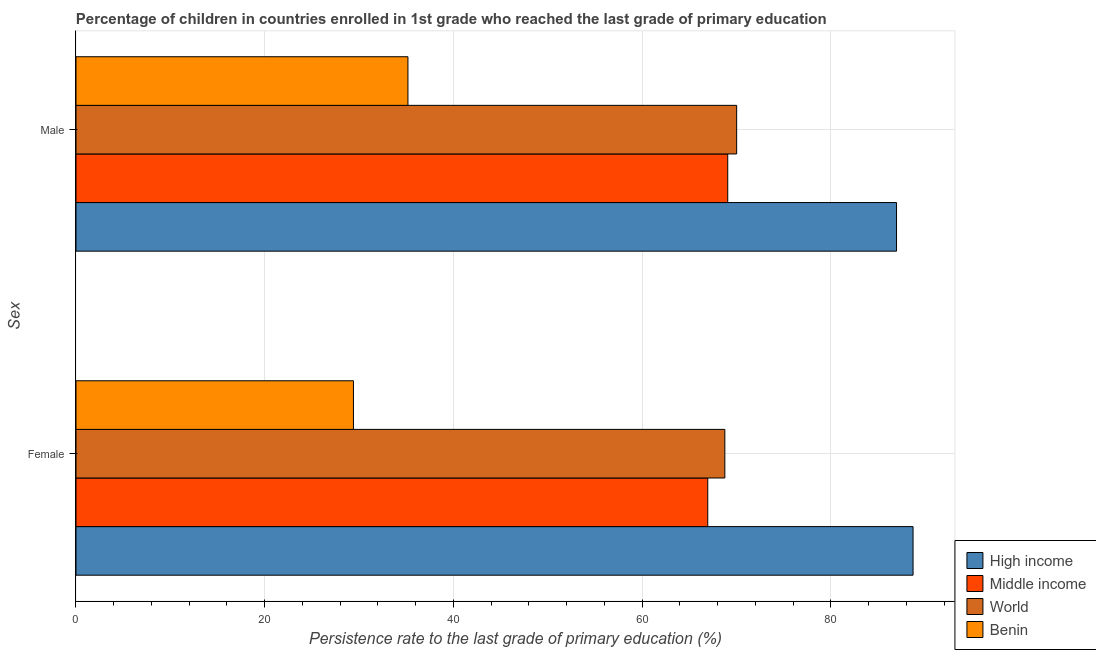How many different coloured bars are there?
Your response must be concise. 4. Are the number of bars per tick equal to the number of legend labels?
Provide a succinct answer. Yes. How many bars are there on the 1st tick from the top?
Provide a short and direct response. 4. What is the persistence rate of female students in Middle income?
Your answer should be compact. 66.95. Across all countries, what is the maximum persistence rate of female students?
Ensure brevity in your answer.  88.71. Across all countries, what is the minimum persistence rate of male students?
Keep it short and to the point. 35.18. In which country was the persistence rate of male students minimum?
Make the answer very short. Benin. What is the total persistence rate of female students in the graph?
Your response must be concise. 253.82. What is the difference between the persistence rate of female students in High income and that in Benin?
Offer a very short reply. 59.3. What is the difference between the persistence rate of female students in High income and the persistence rate of male students in Benin?
Give a very brief answer. 53.53. What is the average persistence rate of female students per country?
Your response must be concise. 63.45. What is the difference between the persistence rate of male students and persistence rate of female students in High income?
Your answer should be very brief. -1.75. What is the ratio of the persistence rate of male students in Middle income to that in Benin?
Ensure brevity in your answer.  1.96. In how many countries, is the persistence rate of male students greater than the average persistence rate of male students taken over all countries?
Provide a succinct answer. 3. How many countries are there in the graph?
Your response must be concise. 4. Are the values on the major ticks of X-axis written in scientific E-notation?
Provide a succinct answer. No. Does the graph contain any zero values?
Keep it short and to the point. No. How many legend labels are there?
Ensure brevity in your answer.  4. How are the legend labels stacked?
Give a very brief answer. Vertical. What is the title of the graph?
Keep it short and to the point. Percentage of children in countries enrolled in 1st grade who reached the last grade of primary education. Does "Estonia" appear as one of the legend labels in the graph?
Your answer should be compact. No. What is the label or title of the X-axis?
Give a very brief answer. Persistence rate to the last grade of primary education (%). What is the label or title of the Y-axis?
Your response must be concise. Sex. What is the Persistence rate to the last grade of primary education (%) of High income in Female?
Give a very brief answer. 88.71. What is the Persistence rate to the last grade of primary education (%) of Middle income in Female?
Offer a terse response. 66.95. What is the Persistence rate to the last grade of primary education (%) of World in Female?
Provide a short and direct response. 68.76. What is the Persistence rate to the last grade of primary education (%) of Benin in Female?
Your response must be concise. 29.4. What is the Persistence rate to the last grade of primary education (%) of High income in Male?
Make the answer very short. 86.95. What is the Persistence rate to the last grade of primary education (%) in Middle income in Male?
Your response must be concise. 69.07. What is the Persistence rate to the last grade of primary education (%) in World in Male?
Make the answer very short. 70.01. What is the Persistence rate to the last grade of primary education (%) in Benin in Male?
Your answer should be very brief. 35.18. Across all Sex, what is the maximum Persistence rate to the last grade of primary education (%) of High income?
Ensure brevity in your answer.  88.71. Across all Sex, what is the maximum Persistence rate to the last grade of primary education (%) of Middle income?
Your answer should be very brief. 69.07. Across all Sex, what is the maximum Persistence rate to the last grade of primary education (%) of World?
Offer a very short reply. 70.01. Across all Sex, what is the maximum Persistence rate to the last grade of primary education (%) in Benin?
Keep it short and to the point. 35.18. Across all Sex, what is the minimum Persistence rate to the last grade of primary education (%) of High income?
Keep it short and to the point. 86.95. Across all Sex, what is the minimum Persistence rate to the last grade of primary education (%) of Middle income?
Offer a very short reply. 66.95. Across all Sex, what is the minimum Persistence rate to the last grade of primary education (%) of World?
Your answer should be compact. 68.76. Across all Sex, what is the minimum Persistence rate to the last grade of primary education (%) of Benin?
Ensure brevity in your answer.  29.4. What is the total Persistence rate to the last grade of primary education (%) in High income in the graph?
Make the answer very short. 175.66. What is the total Persistence rate to the last grade of primary education (%) of Middle income in the graph?
Ensure brevity in your answer.  136.02. What is the total Persistence rate to the last grade of primary education (%) of World in the graph?
Make the answer very short. 138.77. What is the total Persistence rate to the last grade of primary education (%) of Benin in the graph?
Offer a very short reply. 64.58. What is the difference between the Persistence rate to the last grade of primary education (%) of High income in Female and that in Male?
Your answer should be very brief. 1.75. What is the difference between the Persistence rate to the last grade of primary education (%) of Middle income in Female and that in Male?
Give a very brief answer. -2.12. What is the difference between the Persistence rate to the last grade of primary education (%) of World in Female and that in Male?
Offer a very short reply. -1.25. What is the difference between the Persistence rate to the last grade of primary education (%) in Benin in Female and that in Male?
Provide a short and direct response. -5.77. What is the difference between the Persistence rate to the last grade of primary education (%) of High income in Female and the Persistence rate to the last grade of primary education (%) of Middle income in Male?
Keep it short and to the point. 19.64. What is the difference between the Persistence rate to the last grade of primary education (%) in High income in Female and the Persistence rate to the last grade of primary education (%) in World in Male?
Provide a short and direct response. 18.69. What is the difference between the Persistence rate to the last grade of primary education (%) of High income in Female and the Persistence rate to the last grade of primary education (%) of Benin in Male?
Your response must be concise. 53.53. What is the difference between the Persistence rate to the last grade of primary education (%) in Middle income in Female and the Persistence rate to the last grade of primary education (%) in World in Male?
Make the answer very short. -3.06. What is the difference between the Persistence rate to the last grade of primary education (%) of Middle income in Female and the Persistence rate to the last grade of primary education (%) of Benin in Male?
Give a very brief answer. 31.77. What is the difference between the Persistence rate to the last grade of primary education (%) of World in Female and the Persistence rate to the last grade of primary education (%) of Benin in Male?
Provide a succinct answer. 33.58. What is the average Persistence rate to the last grade of primary education (%) of High income per Sex?
Give a very brief answer. 87.83. What is the average Persistence rate to the last grade of primary education (%) in Middle income per Sex?
Make the answer very short. 68.01. What is the average Persistence rate to the last grade of primary education (%) in World per Sex?
Your answer should be compact. 69.39. What is the average Persistence rate to the last grade of primary education (%) in Benin per Sex?
Give a very brief answer. 32.29. What is the difference between the Persistence rate to the last grade of primary education (%) of High income and Persistence rate to the last grade of primary education (%) of Middle income in Female?
Offer a very short reply. 21.76. What is the difference between the Persistence rate to the last grade of primary education (%) in High income and Persistence rate to the last grade of primary education (%) in World in Female?
Make the answer very short. 19.95. What is the difference between the Persistence rate to the last grade of primary education (%) of High income and Persistence rate to the last grade of primary education (%) of Benin in Female?
Provide a short and direct response. 59.3. What is the difference between the Persistence rate to the last grade of primary education (%) of Middle income and Persistence rate to the last grade of primary education (%) of World in Female?
Make the answer very short. -1.81. What is the difference between the Persistence rate to the last grade of primary education (%) of Middle income and Persistence rate to the last grade of primary education (%) of Benin in Female?
Ensure brevity in your answer.  37.55. What is the difference between the Persistence rate to the last grade of primary education (%) of World and Persistence rate to the last grade of primary education (%) of Benin in Female?
Make the answer very short. 39.36. What is the difference between the Persistence rate to the last grade of primary education (%) in High income and Persistence rate to the last grade of primary education (%) in Middle income in Male?
Give a very brief answer. 17.89. What is the difference between the Persistence rate to the last grade of primary education (%) in High income and Persistence rate to the last grade of primary education (%) in World in Male?
Your answer should be very brief. 16.94. What is the difference between the Persistence rate to the last grade of primary education (%) of High income and Persistence rate to the last grade of primary education (%) of Benin in Male?
Keep it short and to the point. 51.78. What is the difference between the Persistence rate to the last grade of primary education (%) of Middle income and Persistence rate to the last grade of primary education (%) of World in Male?
Offer a very short reply. -0.94. What is the difference between the Persistence rate to the last grade of primary education (%) in Middle income and Persistence rate to the last grade of primary education (%) in Benin in Male?
Provide a short and direct response. 33.89. What is the difference between the Persistence rate to the last grade of primary education (%) of World and Persistence rate to the last grade of primary education (%) of Benin in Male?
Offer a terse response. 34.83. What is the ratio of the Persistence rate to the last grade of primary education (%) of High income in Female to that in Male?
Ensure brevity in your answer.  1.02. What is the ratio of the Persistence rate to the last grade of primary education (%) of Middle income in Female to that in Male?
Make the answer very short. 0.97. What is the ratio of the Persistence rate to the last grade of primary education (%) in World in Female to that in Male?
Give a very brief answer. 0.98. What is the ratio of the Persistence rate to the last grade of primary education (%) in Benin in Female to that in Male?
Your answer should be compact. 0.84. What is the difference between the highest and the second highest Persistence rate to the last grade of primary education (%) of High income?
Make the answer very short. 1.75. What is the difference between the highest and the second highest Persistence rate to the last grade of primary education (%) of Middle income?
Your response must be concise. 2.12. What is the difference between the highest and the second highest Persistence rate to the last grade of primary education (%) of World?
Make the answer very short. 1.25. What is the difference between the highest and the second highest Persistence rate to the last grade of primary education (%) of Benin?
Give a very brief answer. 5.77. What is the difference between the highest and the lowest Persistence rate to the last grade of primary education (%) in High income?
Provide a succinct answer. 1.75. What is the difference between the highest and the lowest Persistence rate to the last grade of primary education (%) of Middle income?
Offer a very short reply. 2.12. What is the difference between the highest and the lowest Persistence rate to the last grade of primary education (%) in World?
Make the answer very short. 1.25. What is the difference between the highest and the lowest Persistence rate to the last grade of primary education (%) of Benin?
Offer a very short reply. 5.77. 